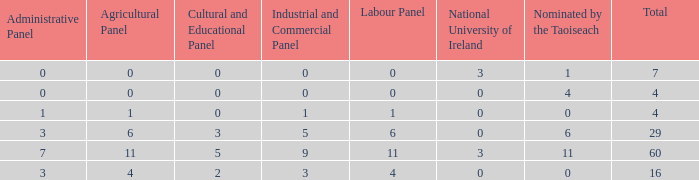What is the median agricultural panel of the composition with a labour panel under 6, over 0 nominations by taoiseach, and a total quantity fewer than 4? None. Would you be able to parse every entry in this table? {'header': ['Administrative Panel', 'Agricultural Panel', 'Cultural and Educational Panel', 'Industrial and Commercial Panel', 'Labour Panel', 'National University of Ireland', 'Nominated by the Taoiseach', 'Total'], 'rows': [['0', '0', '0', '0', '0', '3', '1', '7'], ['0', '0', '0', '0', '0', '0', '4', '4'], ['1', '1', '0', '1', '1', '0', '0', '4'], ['3', '6', '3', '5', '6', '0', '6', '29'], ['7', '11', '5', '9', '11', '3', '11', '60'], ['3', '4', '2', '3', '4', '0', '0', '16']]} 